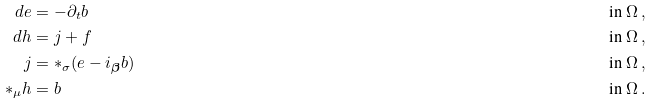Convert formula to latex. <formula><loc_0><loc_0><loc_500><loc_500>d e & = - \partial _ { t } b & \text {in $\Omega$} \, , \\ d h & = j + f & \text {in $\Omega$} \, , \\ j & = \ast _ { \sigma } ( e - i _ { \boldsymbol \beta } b ) & \text {in $\Omega$} \, , \\ \ast _ { \mu } h & = b & \text {in $\Omega$} \, .</formula> 